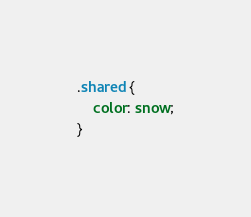<code> <loc_0><loc_0><loc_500><loc_500><_CSS_>.shared {
    color: snow;
}
</code> 